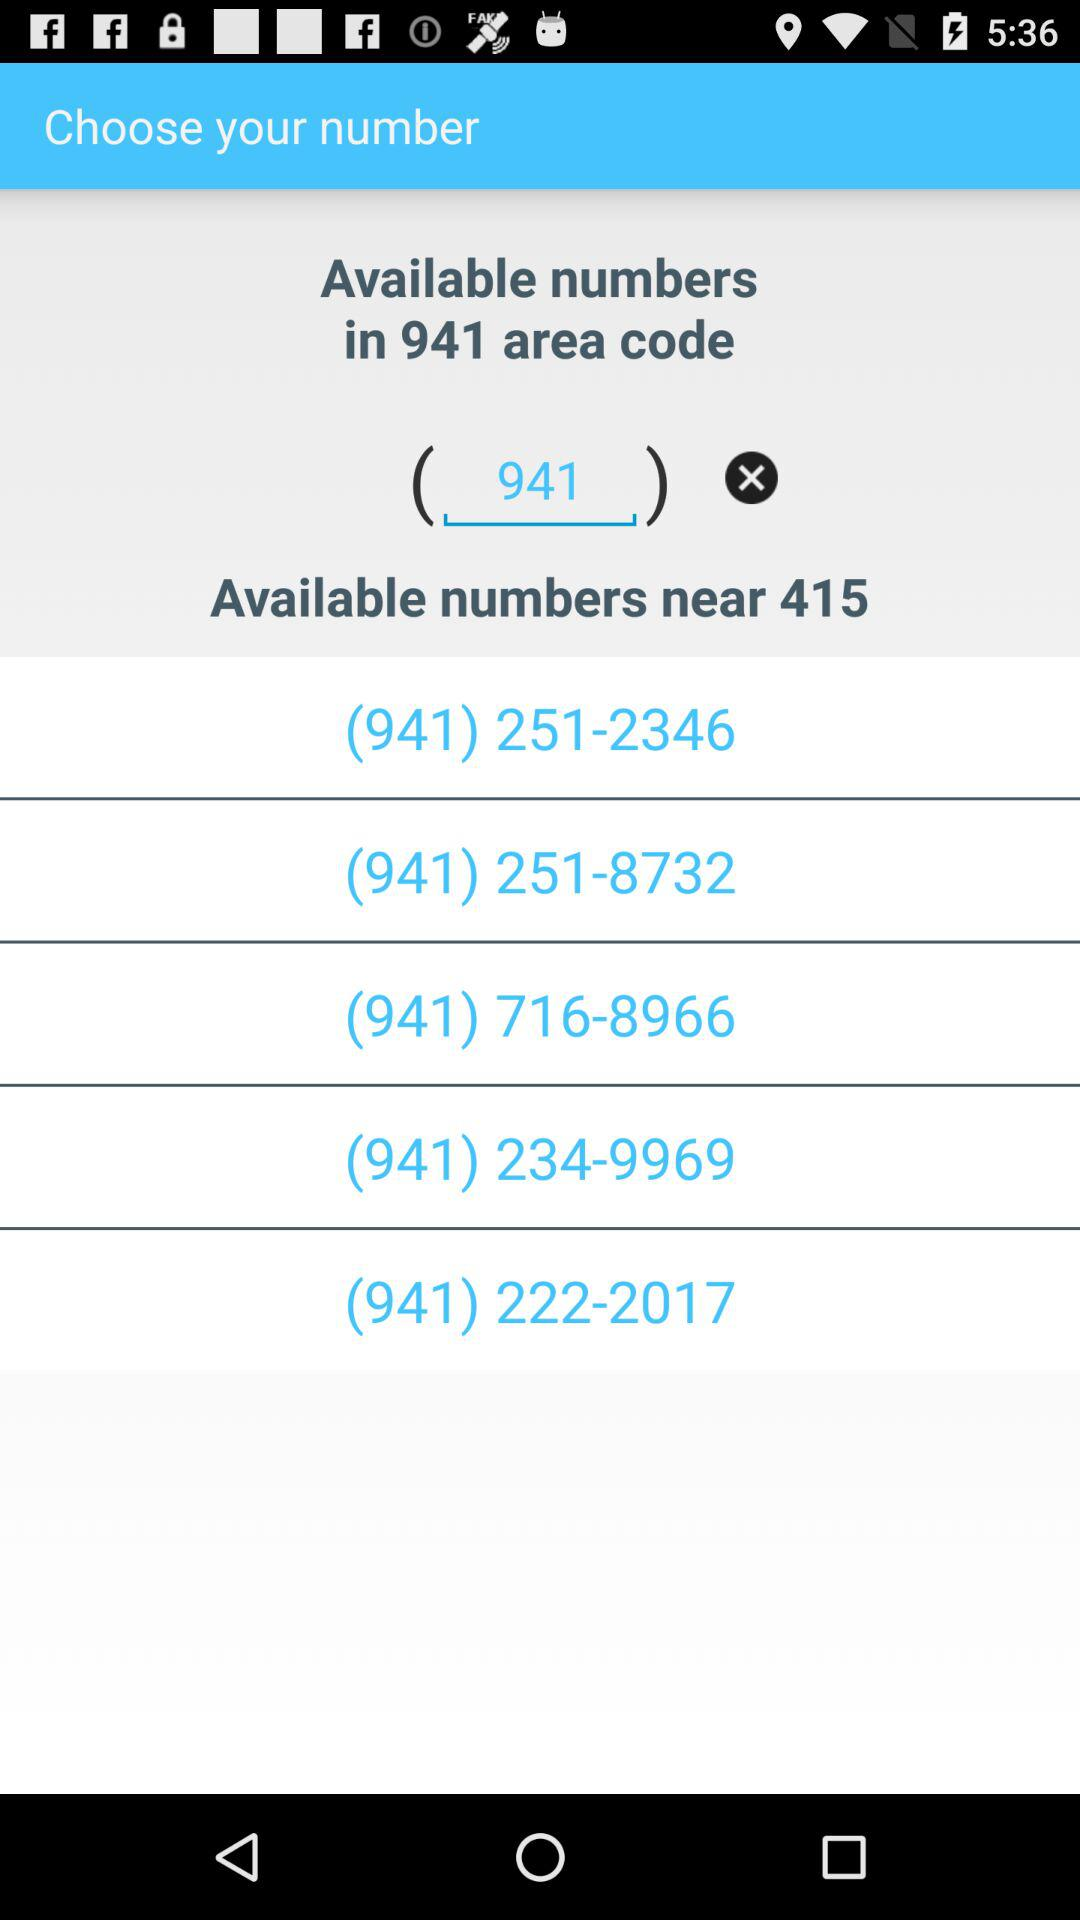How many available numbers are there?
When the provided information is insufficient, respond with <no answer>. <no answer> 